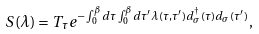Convert formula to latex. <formula><loc_0><loc_0><loc_500><loc_500>S ( \lambda ) = T _ { \tau } e ^ { - \int _ { 0 } ^ { \beta } d \tau \int _ { 0 } ^ { \beta } d \tau ^ { \prime } \lambda ( \tau , \tau ^ { \prime } ) d _ { \sigma } ^ { \dagger } ( \tau ) d _ { \sigma } ( \tau ^ { \prime } ) } ,</formula> 